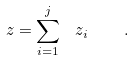Convert formula to latex. <formula><loc_0><loc_0><loc_500><loc_500>z = \sum _ { i = 1 } ^ { j } \ z _ { i } \quad .</formula> 